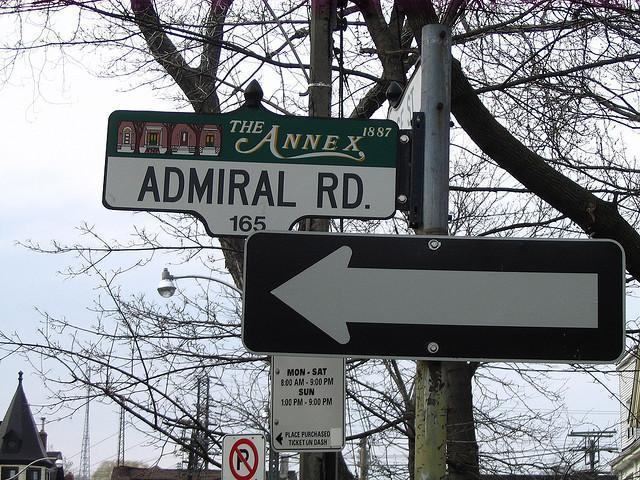How many no parking signs are visible?
Give a very brief answer. 1. 